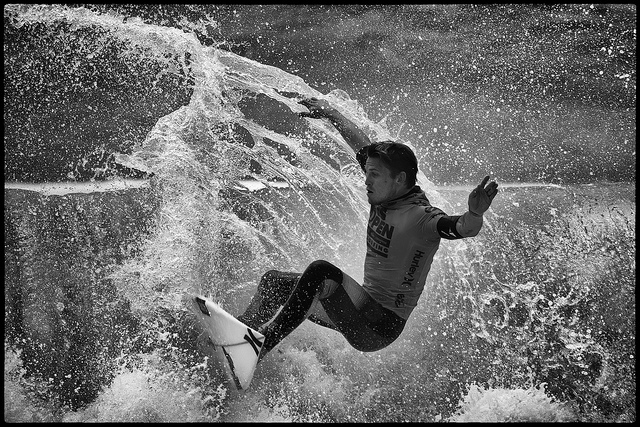Identify the text contained in this image. OPEN Hurley 